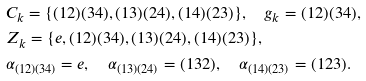<formula> <loc_0><loc_0><loc_500><loc_500>& C _ { k } = \{ ( 1 2 ) ( 3 4 ) , ( 1 3 ) ( 2 4 ) , ( 1 4 ) ( 2 3 ) \} , \quad g _ { k } = ( 1 2 ) ( 3 4 ) , \\ & Z _ { k } = \{ e , ( 1 2 ) ( 3 4 ) , ( 1 3 ) ( 2 4 ) , ( 1 4 ) ( 2 3 ) \} , \\ & \alpha _ { ( 1 2 ) ( 3 4 ) } = e , \quad \alpha _ { ( 1 3 ) ( 2 4 ) } = ( 1 3 2 ) , \quad \alpha _ { ( 1 4 ) ( 2 3 ) } = ( 1 2 3 ) .</formula> 